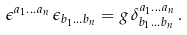<formula> <loc_0><loc_0><loc_500><loc_500>\epsilon ^ { a _ { 1 } \dots a _ { n } } \, \epsilon _ { b _ { 1 } \dots b _ { n } } = g \, \delta ^ { a _ { 1 } \dots a _ { n } } _ { b _ { 1 } \dots b _ { n } } \, .</formula> 